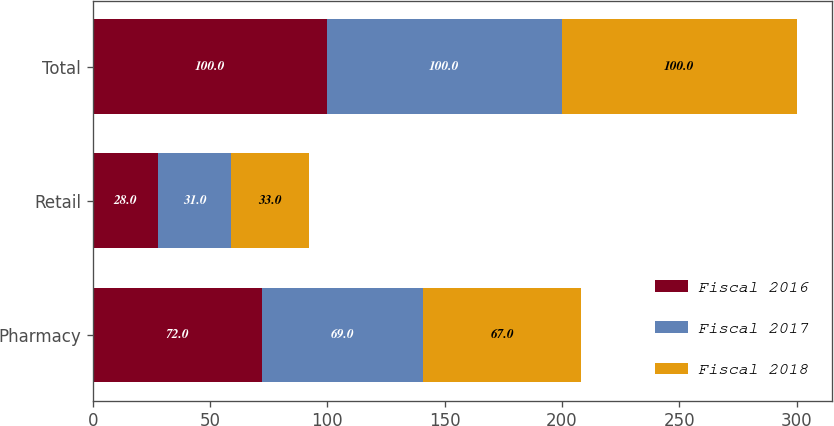<chart> <loc_0><loc_0><loc_500><loc_500><stacked_bar_chart><ecel><fcel>Pharmacy<fcel>Retail<fcel>Total<nl><fcel>Fiscal 2016<fcel>72<fcel>28<fcel>100<nl><fcel>Fiscal 2017<fcel>69<fcel>31<fcel>100<nl><fcel>Fiscal 2018<fcel>67<fcel>33<fcel>100<nl></chart> 